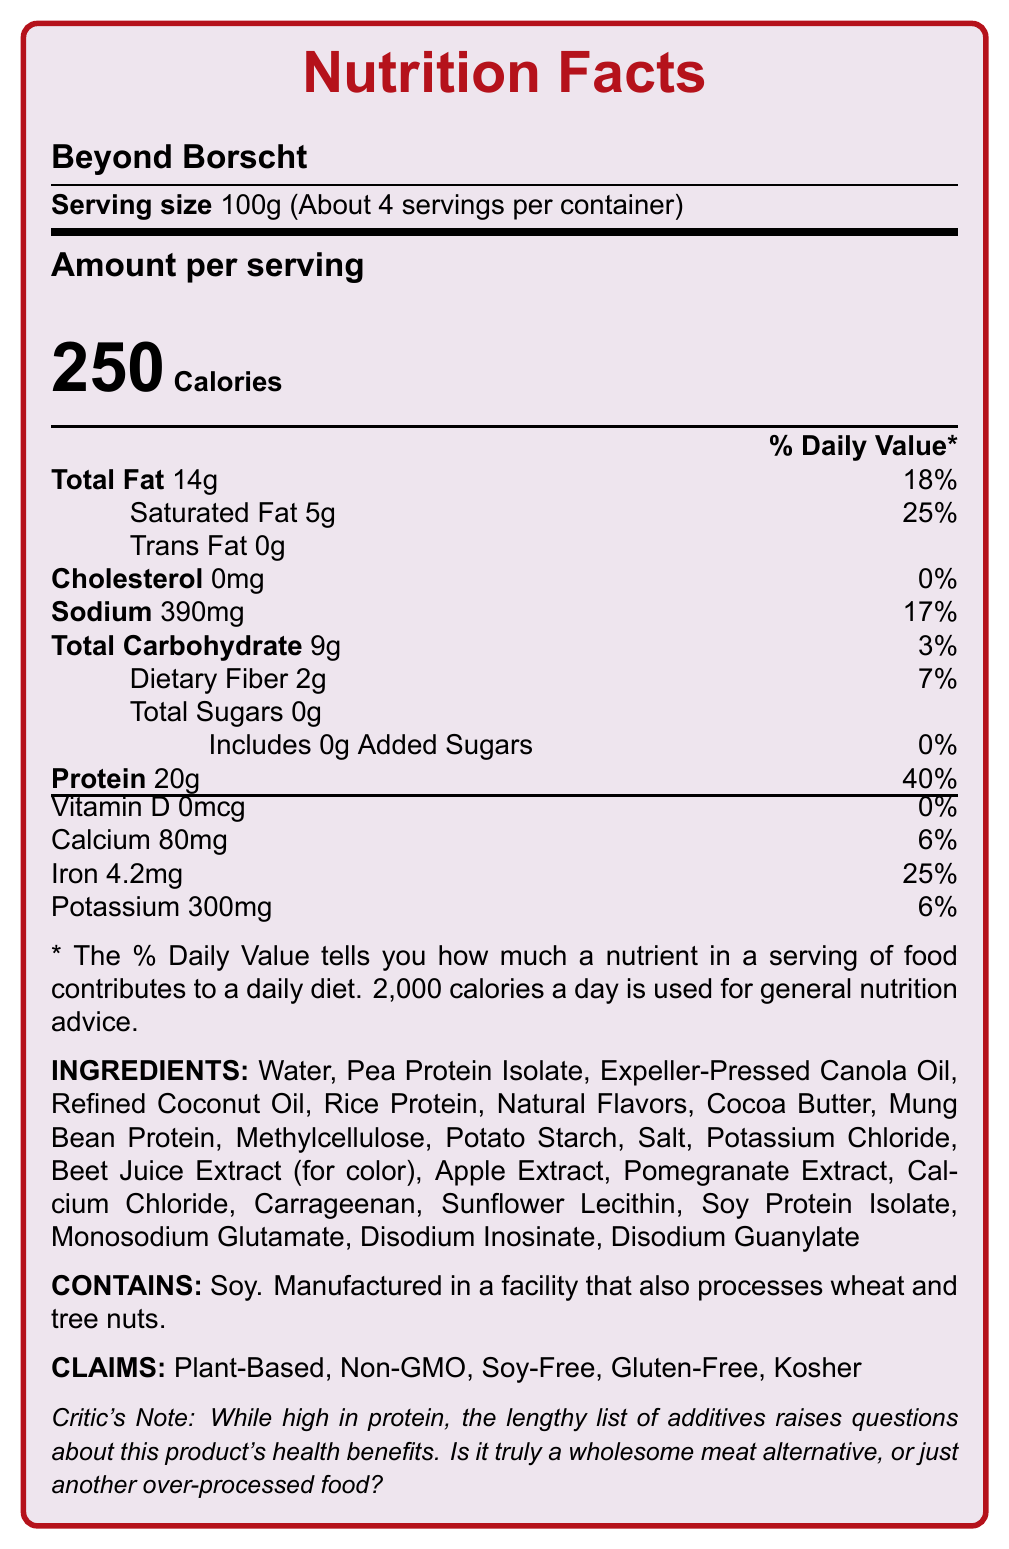what is the serving size? The document states that the serving size is 100g.
Answer: 100g how many calories are there per serving? According to the document, there are 250 calories per serving.
Answer: 250 calories how much protein does a serving contain? The document indicates that a serving contains 20g of protein.
Answer: 20g what is the total fat percentage of the daily value? The total fat percentage of the daily value is listed as 18%.
Answer: 18% list at least three allergens that might be present in the product. The document mentions that the product contains soy and is manufactured in a facility that also processes wheat and tree nuts.
Answer: Soy, Wheat, Tree Nuts what are the total carbohydrates per serving? The document states that there are 9g of total carbohydrates per serving.
Answer: 9g which of the following is NOT an ingredient in "Beyond Borscht"? A. Pea Protein Isolate B. Methylcellulose C. Corn Starch D. Disodium Inosinate The document lists Pea Protein Isolate, Methylcellulose, and Disodium Inosinate as ingredients, but not Corn Starch.
Answer: C. Corn Starch according to the document, what percentage of the daily value of iron does one serving provide? A. 25% B. 18% C. 40% D. 50% The document shows that one serving provides 25% of the daily value of iron.
Answer: A. 25% is the product gluten-free? The document includes a claim stating that the product is gluten-free.
Answer: Yes summarize the main points of the document. This summary description covers the key nutritional information, ingredients, claims, and the critical review provided in the document.
Answer: "Beyond Borscht" is a plant-based meat alternative with a serving size of 100g and contains high protein and calorie content per serving. It includes various ingredients, some of which are controversial additives. The product is gluten-free, soy-free, and non-GMO, but it contains soy and is manufactured in a facility that processes wheat and tree nuts. The product aims to mimic meat but raises questions about its health benefits due to the artificial ingredients. how much saturated fat is there per serving? The document notes that each serving contains 5g of saturated fat.
Answer: 5g what additives in the product might be considered controversial? The document mentions that the inclusion of carrageenan and monosodium glutamate as ingredients might be considered controversial.
Answer: Carrageenan, Monosodium Glutamate which vitamin is completely absent in a serving of "Beyond Borscht"? The document indicates that Vitamin D is 0mcg per serving.
Answer: Vitamin D what is the color used for drawing lines in the nutrition facts section? The document specifies that Russian Red is used for drawing lines.
Answer: Russian Red can you determine the cost of the product from the document's information? The document does not provide any information about the cost of the product.
Answer: Cannot be determined 